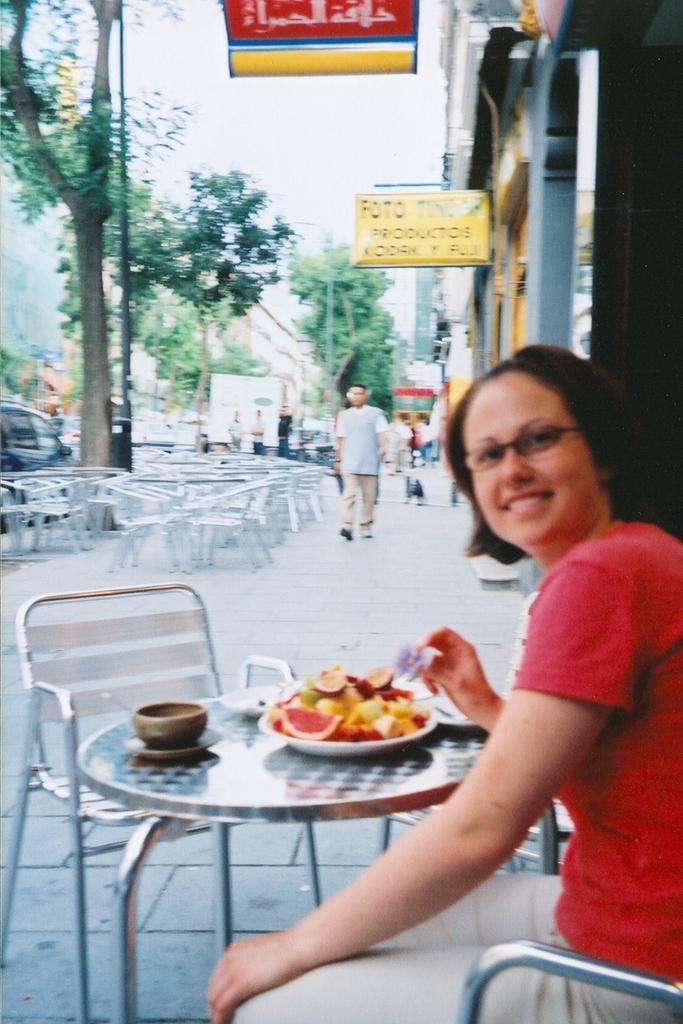Please provide a concise description of this image. In this image i can see a woman sitting there are some fruits in a plate, a bowl on a table in the back ground i can see a person walking, few chairs, a tree, board , sky, building. 